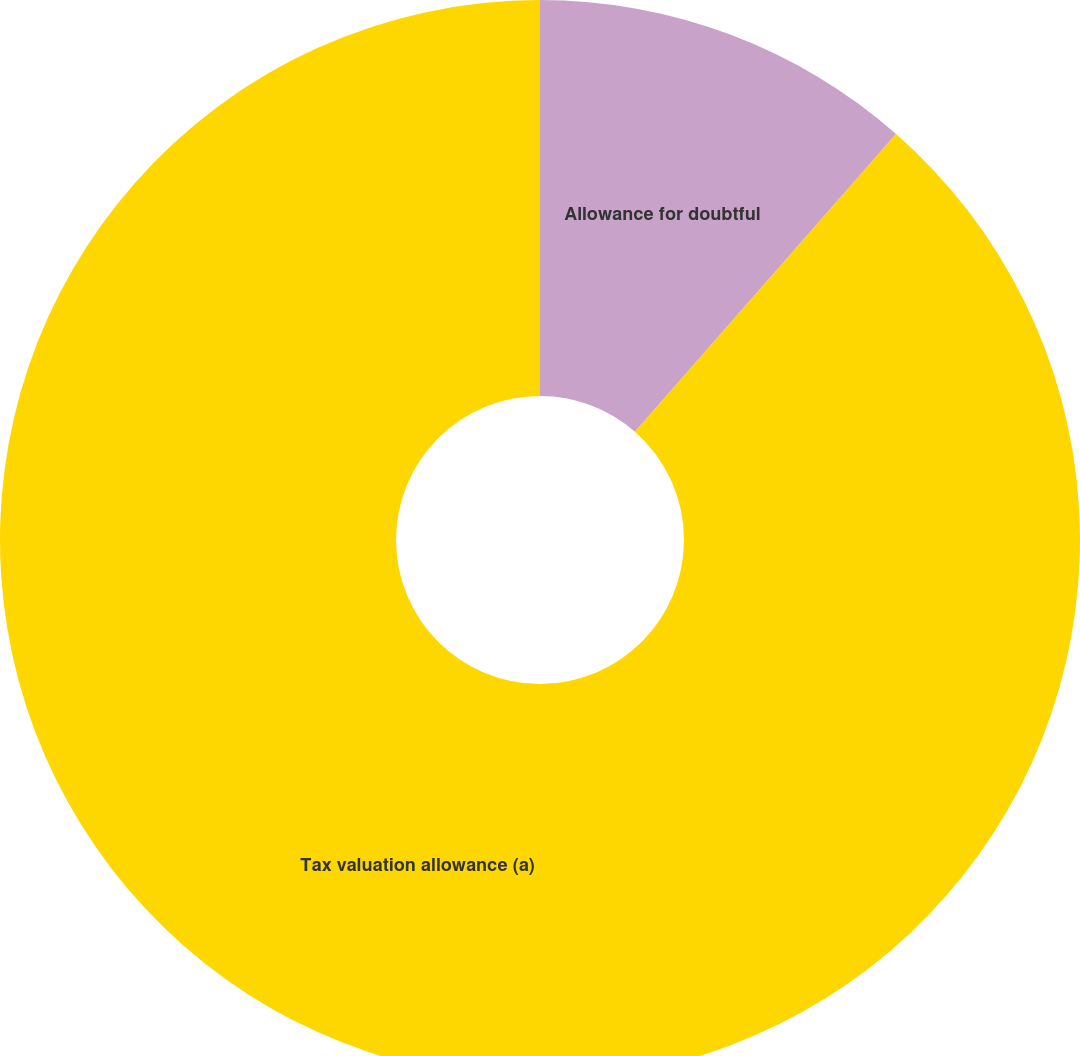<chart> <loc_0><loc_0><loc_500><loc_500><pie_chart><fcel>Allowance for doubtful<fcel>Tax valuation allowance (a)<nl><fcel>11.46%<fcel>88.54%<nl></chart> 